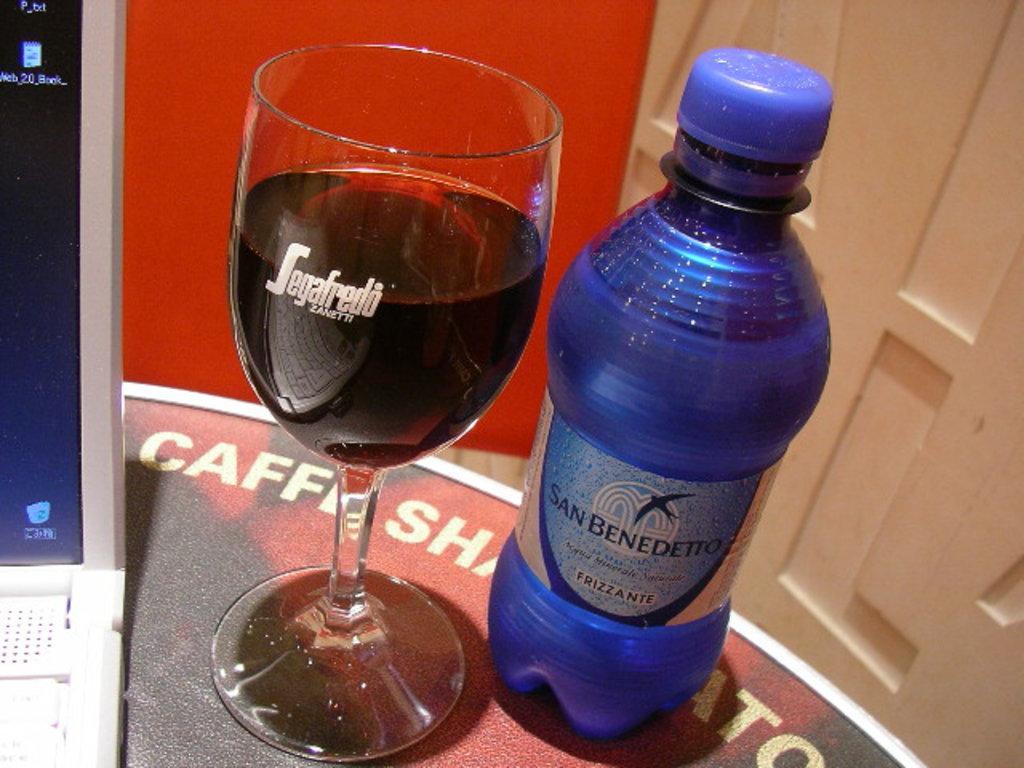Please provide a concise description of this image. There is a bottle and glass on the table,beside them there is a laptop. 